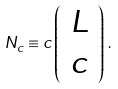Convert formula to latex. <formula><loc_0><loc_0><loc_500><loc_500>N _ { c } \equiv c \left ( \begin{array} { c } L \\ c \end{array} \right ) \, .</formula> 